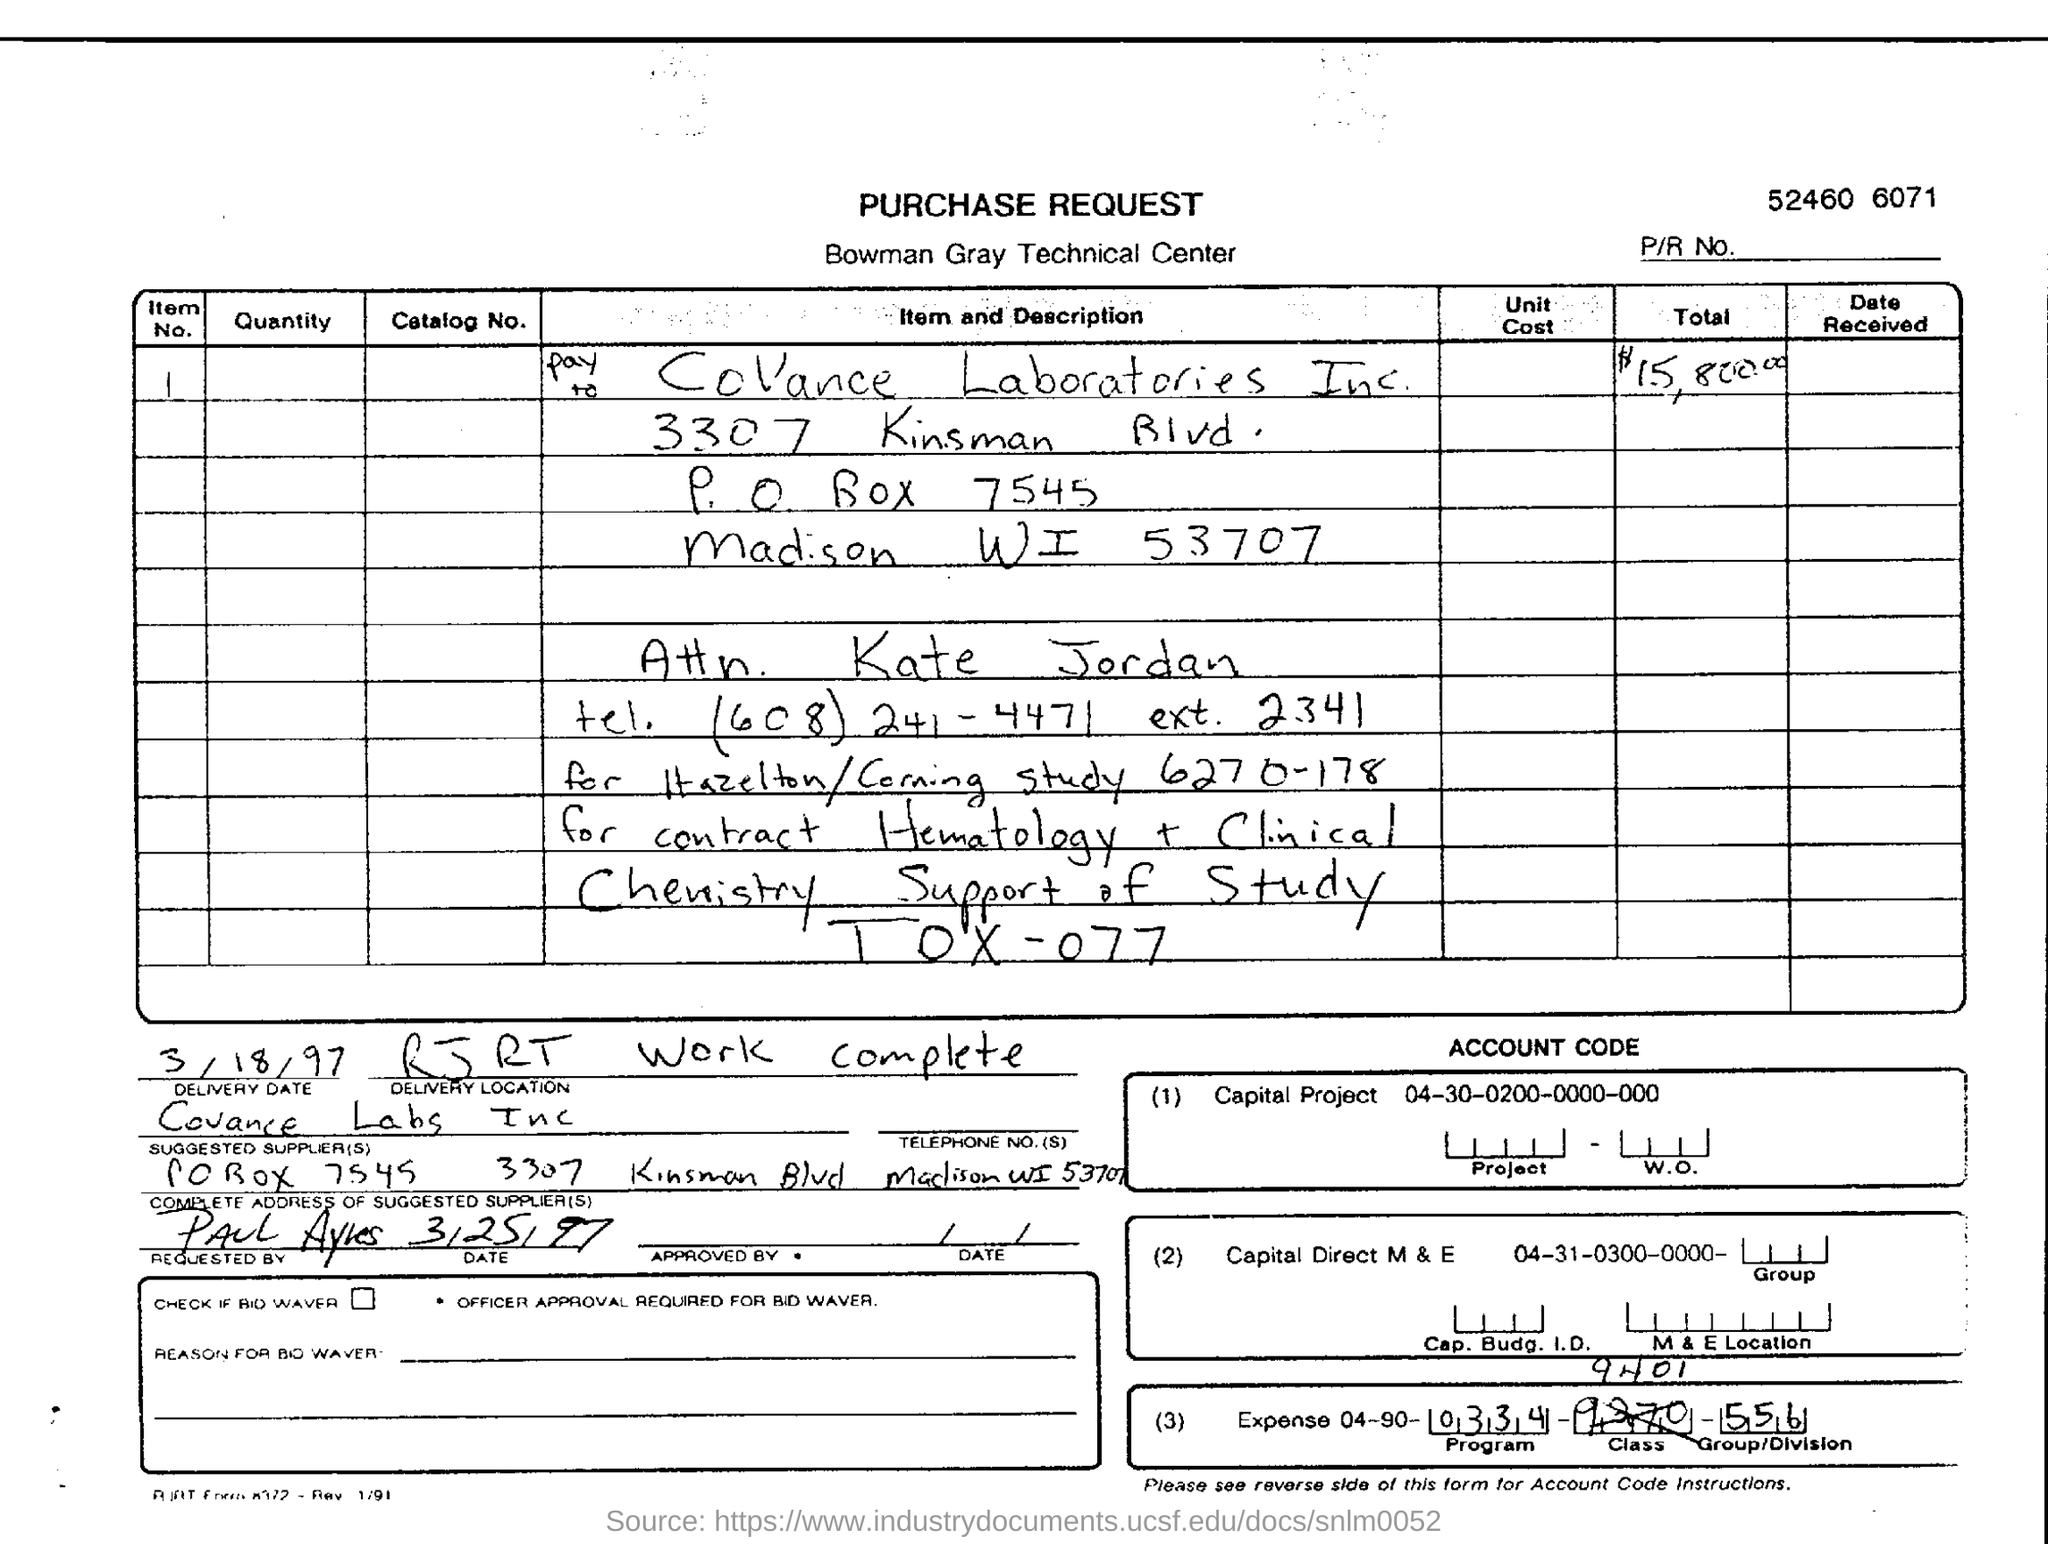What is the total amount mentioned in the purchase request form?
Make the answer very short. $15,800.00. What is the delivery date given in the purchase request form?
Your response must be concise. 3/18/97. Who is the suggested supplier as given in the form?
Offer a terse response. Covance Labs Inc. What is the item no. given in the purchase request form?
Keep it short and to the point. 1. Which company's purchase request form is this?
Make the answer very short. Bowman gray technical center. 